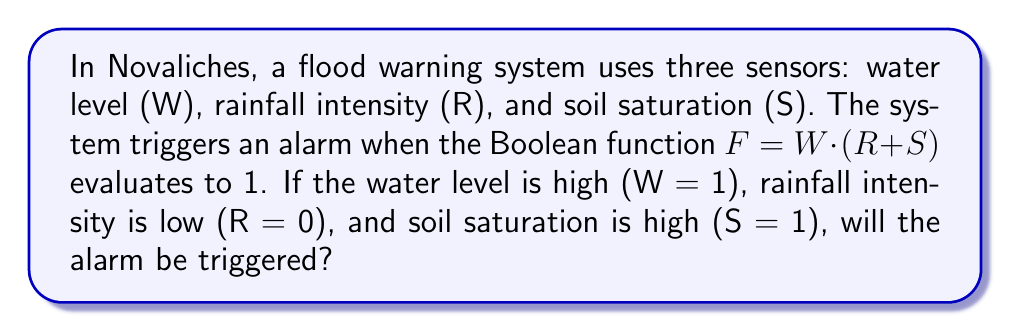Can you solve this math problem? Let's approach this step-by-step:

1) We are given the Boolean function: $F = W \cdot (R + S)$

2) We need to evaluate this function with the following inputs:
   W = 1 (water level is high)
   R = 0 (rainfall intensity is low)
   S = 1 (soil saturation is high)

3) Let's start with the expression inside the parentheses: $(R + S)$
   $R + S = 0 + 1 = 1$

4) Now our function looks like this:
   $F = W \cdot 1$

5) We can now substitute the value for W:
   $F = 1 \cdot 1 = 1$

6) In Boolean algebra, 1 represents TRUE.

Therefore, when $F = 1$, the alarm will be triggered.
Answer: Yes 